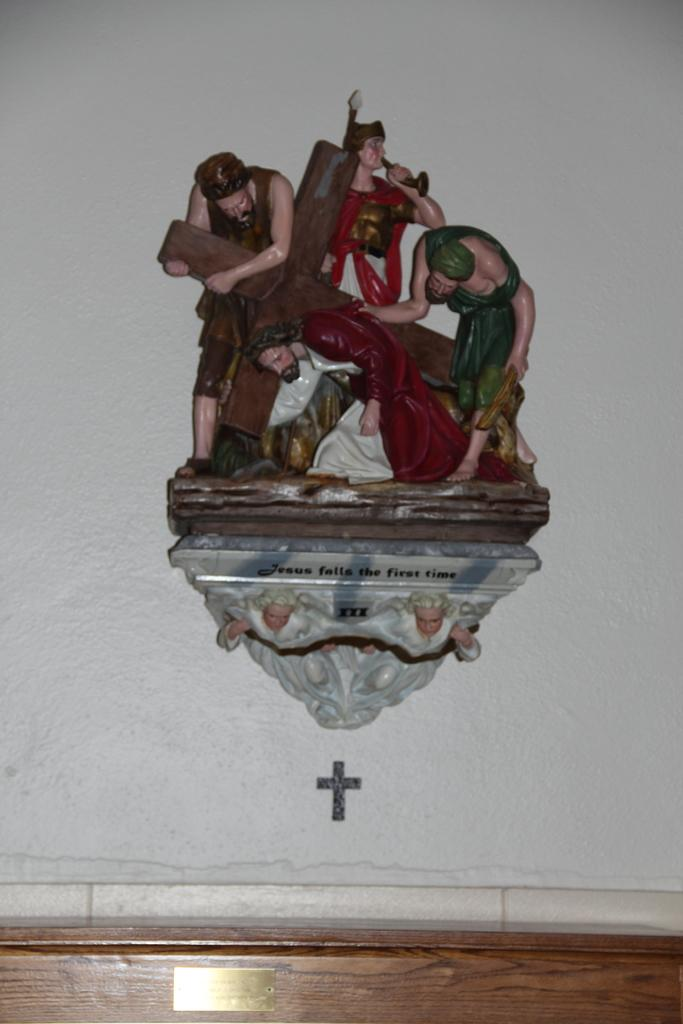What can be seen in the image that resembles art? There are sculptures in the image. What are the sculptures placed on? The sculptures are on an object. What type of material is visible at the bottom of the image? There is a wooden board at the bottom of the image. What songs are being played on the apparatus in the image? There is no apparatus or music playing in the image; it features sculptures on an object and a wooden board at the bottom. 